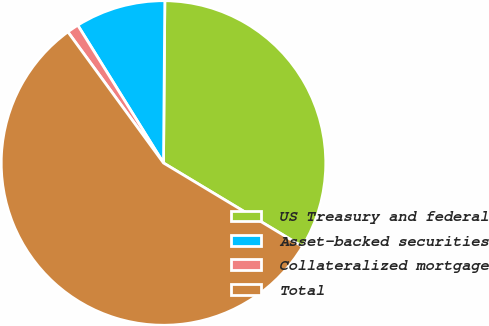<chart> <loc_0><loc_0><loc_500><loc_500><pie_chart><fcel>US Treasury and federal<fcel>Asset-backed securities<fcel>Collateralized mortgage<fcel>Total<nl><fcel>33.49%<fcel>8.99%<fcel>1.17%<fcel>56.35%<nl></chart> 